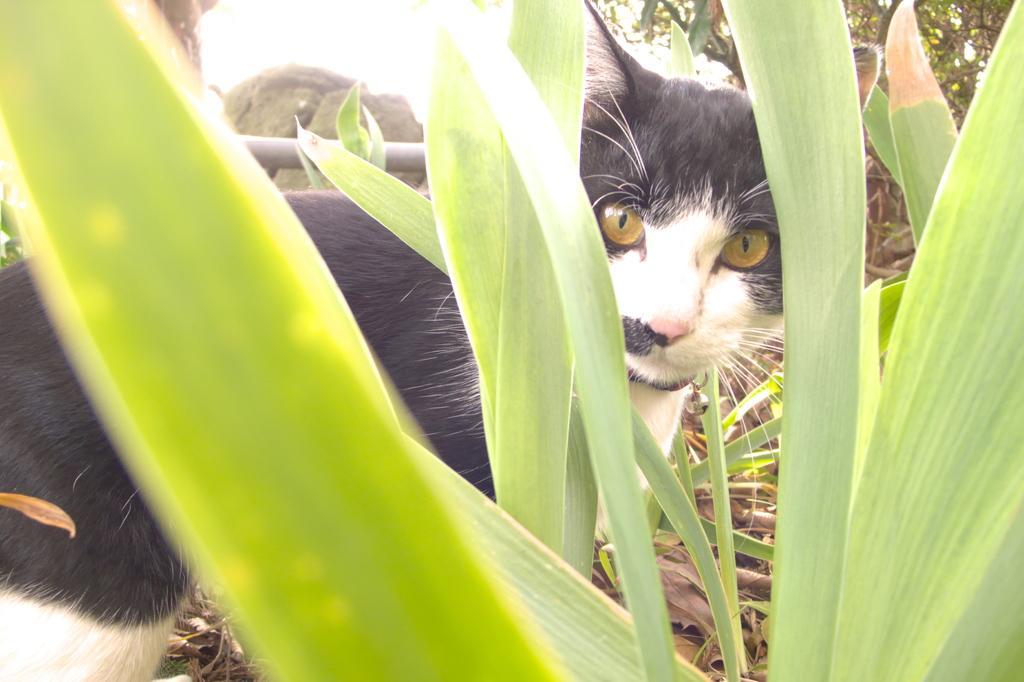Please provide a concise description of this image. In this image we can see there is a cat in between the leaves. In the background there are trees on the right side. On the left side it looks like a pole in the background. 